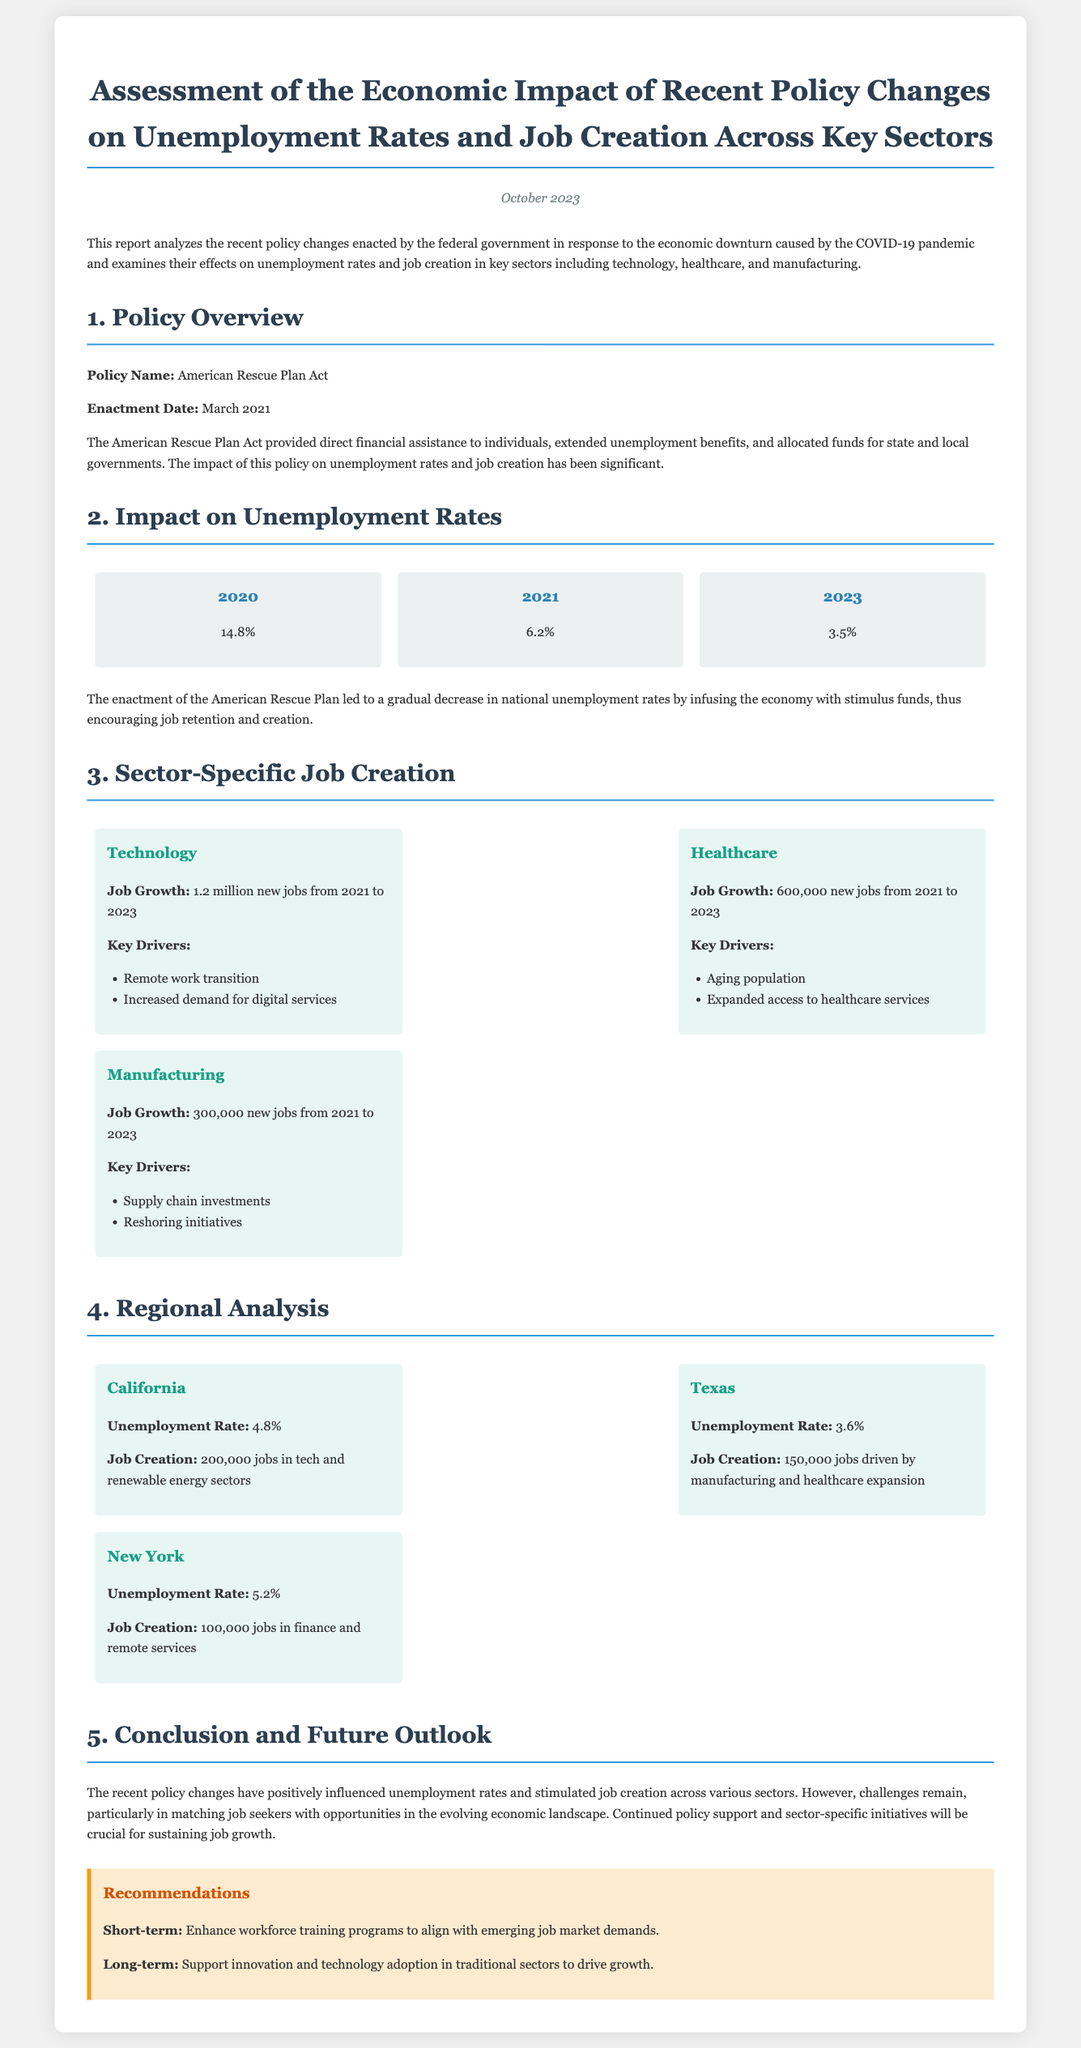What is the main policy discussed in this report? The main policy discussed in the report is the American Rescue Plan Act, which provided economic assistance in response to the COVID-19 pandemic.
Answer: American Rescue Plan Act What year did the unemployment rate peak according to the report? The unemployment rate peaked at 14.8% in 2020 as mentioned in the document.
Answer: 2020 How many jobs were created in the healthcare sector from 2021 to 2023? The healthcare sector saw a job growth of 600,000 new jobs during this period as specified in the report.
Answer: 600,000 new jobs What was California's unemployment rate as of the report's date? California's unemployment rate is reported to be 4.8%.
Answer: 4.8% What is a key driver for job growth in the technology sector? A key driver for job growth in the technology sector is the remote work transition, which is highlighted in the document.
Answer: Remote work transition How many new jobs were created in the manufacturing sector? The manufacturing sector created 300,000 new jobs from 2021 to 2023 according to the findings in the report.
Answer: 300,000 new jobs What recommendation is made for the short-term? The report recommends enhancing workforce training programs to align with emerging job market demands as a short-term solution.
Answer: Enhance workforce training programs What was the unemployment rate in Texas according to the report? The unemployment rate in Texas is stated as 3.6% in the document.
Answer: 3.6% What is the total job growth for the technology sector from 2021 to 2023? The total job growth for the technology sector is stated as 1.2 million new jobs in the report.
Answer: 1.2 million new jobs 